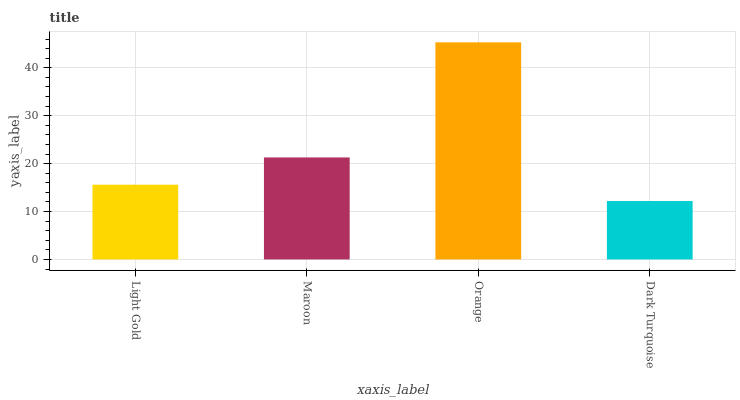Is Dark Turquoise the minimum?
Answer yes or no. Yes. Is Orange the maximum?
Answer yes or no. Yes. Is Maroon the minimum?
Answer yes or no. No. Is Maroon the maximum?
Answer yes or no. No. Is Maroon greater than Light Gold?
Answer yes or no. Yes. Is Light Gold less than Maroon?
Answer yes or no. Yes. Is Light Gold greater than Maroon?
Answer yes or no. No. Is Maroon less than Light Gold?
Answer yes or no. No. Is Maroon the high median?
Answer yes or no. Yes. Is Light Gold the low median?
Answer yes or no. Yes. Is Dark Turquoise the high median?
Answer yes or no. No. Is Orange the low median?
Answer yes or no. No. 